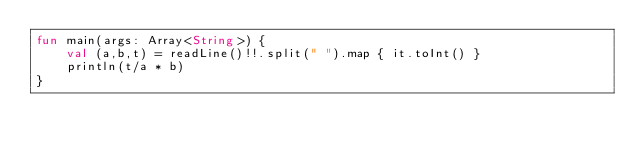<code> <loc_0><loc_0><loc_500><loc_500><_Kotlin_>fun main(args: Array<String>) {
    val (a,b,t) = readLine()!!.split(" ").map { it.toInt() }
    println(t/a * b)
}
</code> 